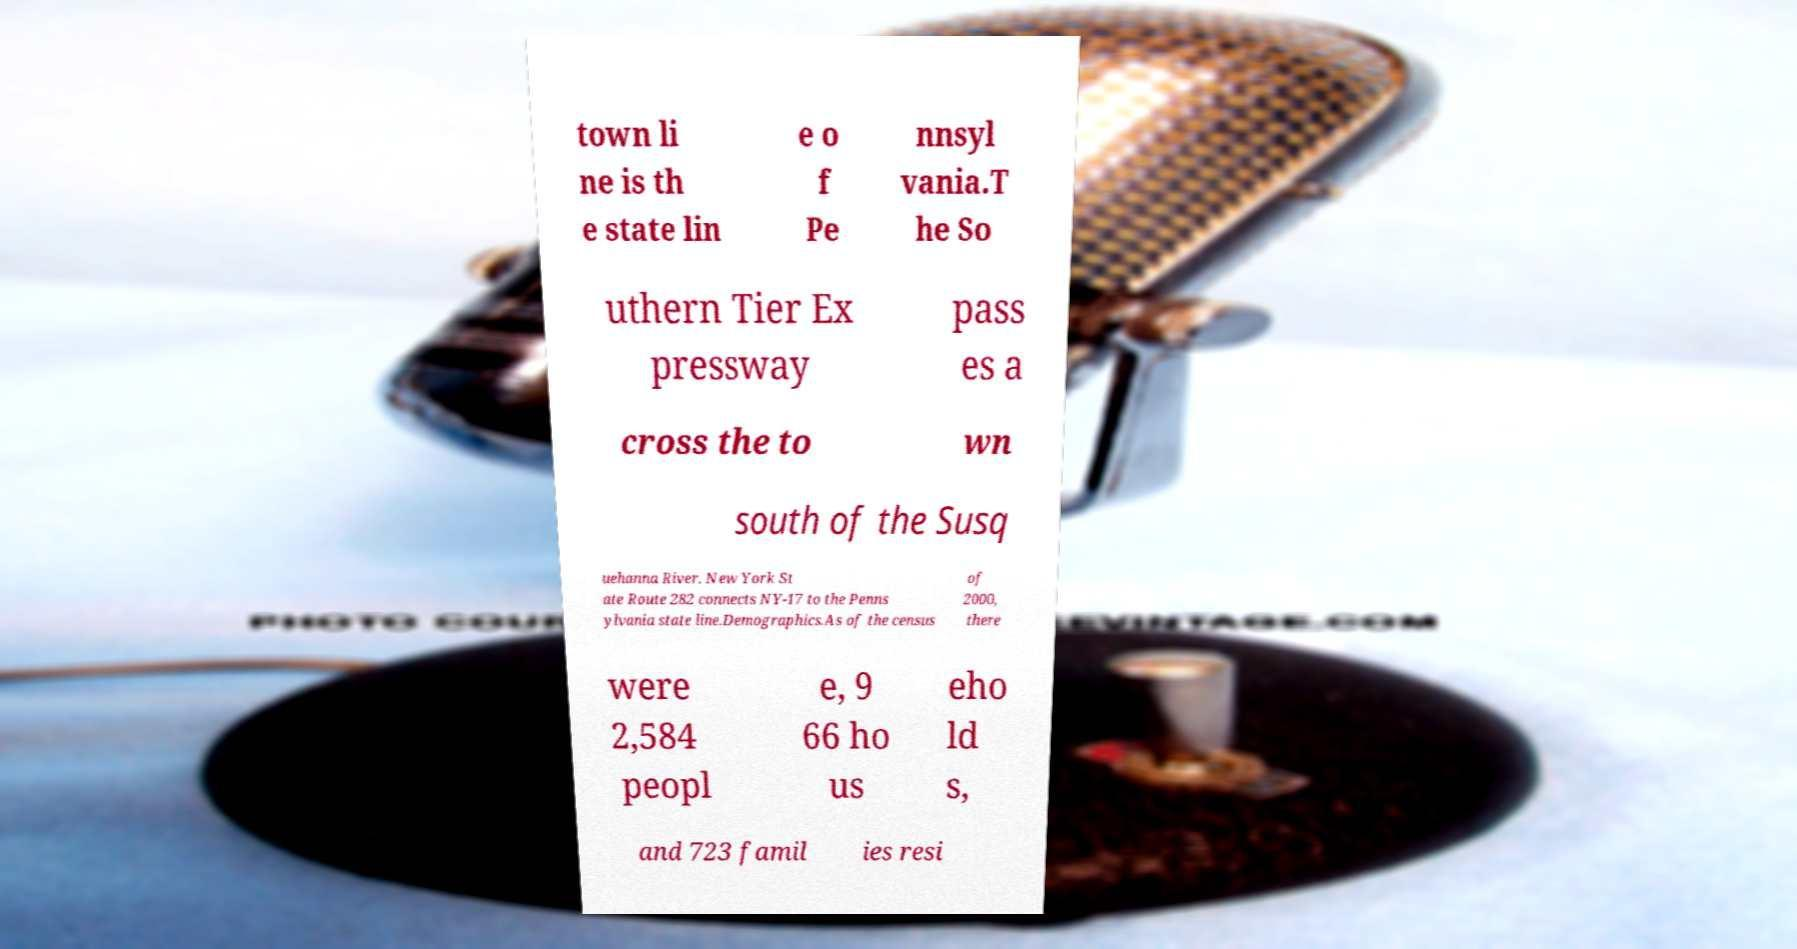Could you extract and type out the text from this image? town li ne is th e state lin e o f Pe nnsyl vania.T he So uthern Tier Ex pressway pass es a cross the to wn south of the Susq uehanna River. New York St ate Route 282 connects NY-17 to the Penns ylvania state line.Demographics.As of the census of 2000, there were 2,584 peopl e, 9 66 ho us eho ld s, and 723 famil ies resi 